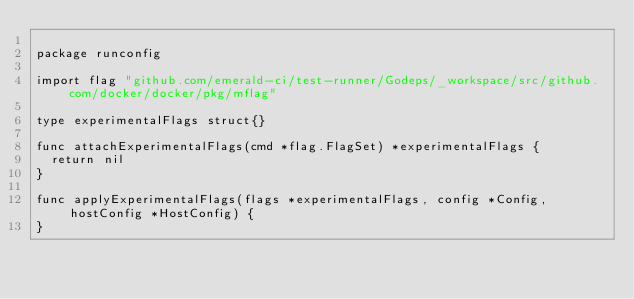<code> <loc_0><loc_0><loc_500><loc_500><_Go_>
package runconfig

import flag "github.com/emerald-ci/test-runner/Godeps/_workspace/src/github.com/docker/docker/pkg/mflag"

type experimentalFlags struct{}

func attachExperimentalFlags(cmd *flag.FlagSet) *experimentalFlags {
	return nil
}

func applyExperimentalFlags(flags *experimentalFlags, config *Config, hostConfig *HostConfig) {
}
</code> 